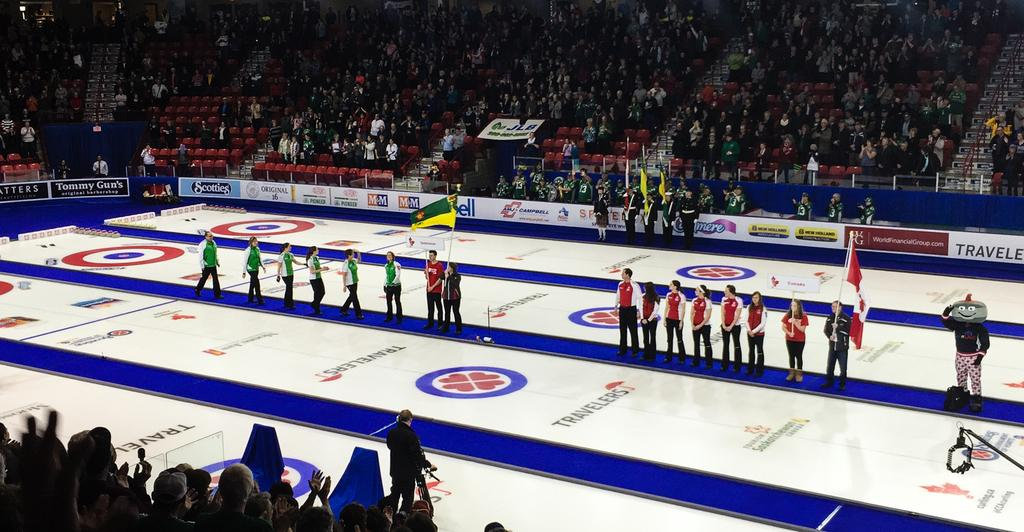<image>
Provide a brief description of the given image. A number of people are gathered at a curling arena that is sponsored by Travelers. 